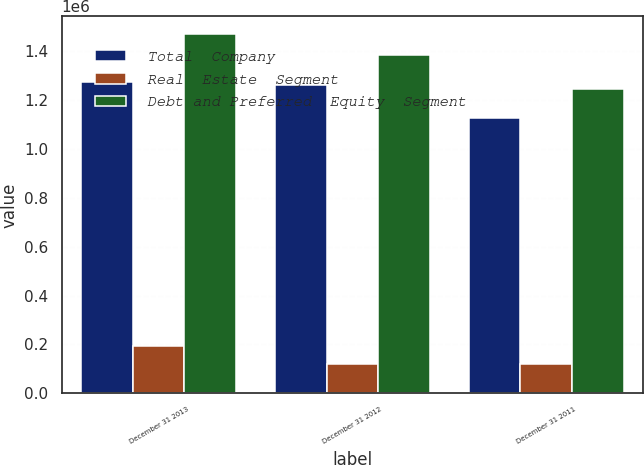<chart> <loc_0><loc_0><loc_500><loc_500><stacked_bar_chart><ecel><fcel>December 31 2013<fcel>December 31 2012<fcel>December 31 2011<nl><fcel>Total  Company<fcel>1.27523e+06<fcel>1.26357e+06<fcel>1.12644e+06<nl><fcel>Real  Estate  Segment<fcel>193843<fcel>119155<fcel>120418<nl><fcel>Debt and Preferred  Equity  Segment<fcel>1.46908e+06<fcel>1.38273e+06<fcel>1.24686e+06<nl></chart> 